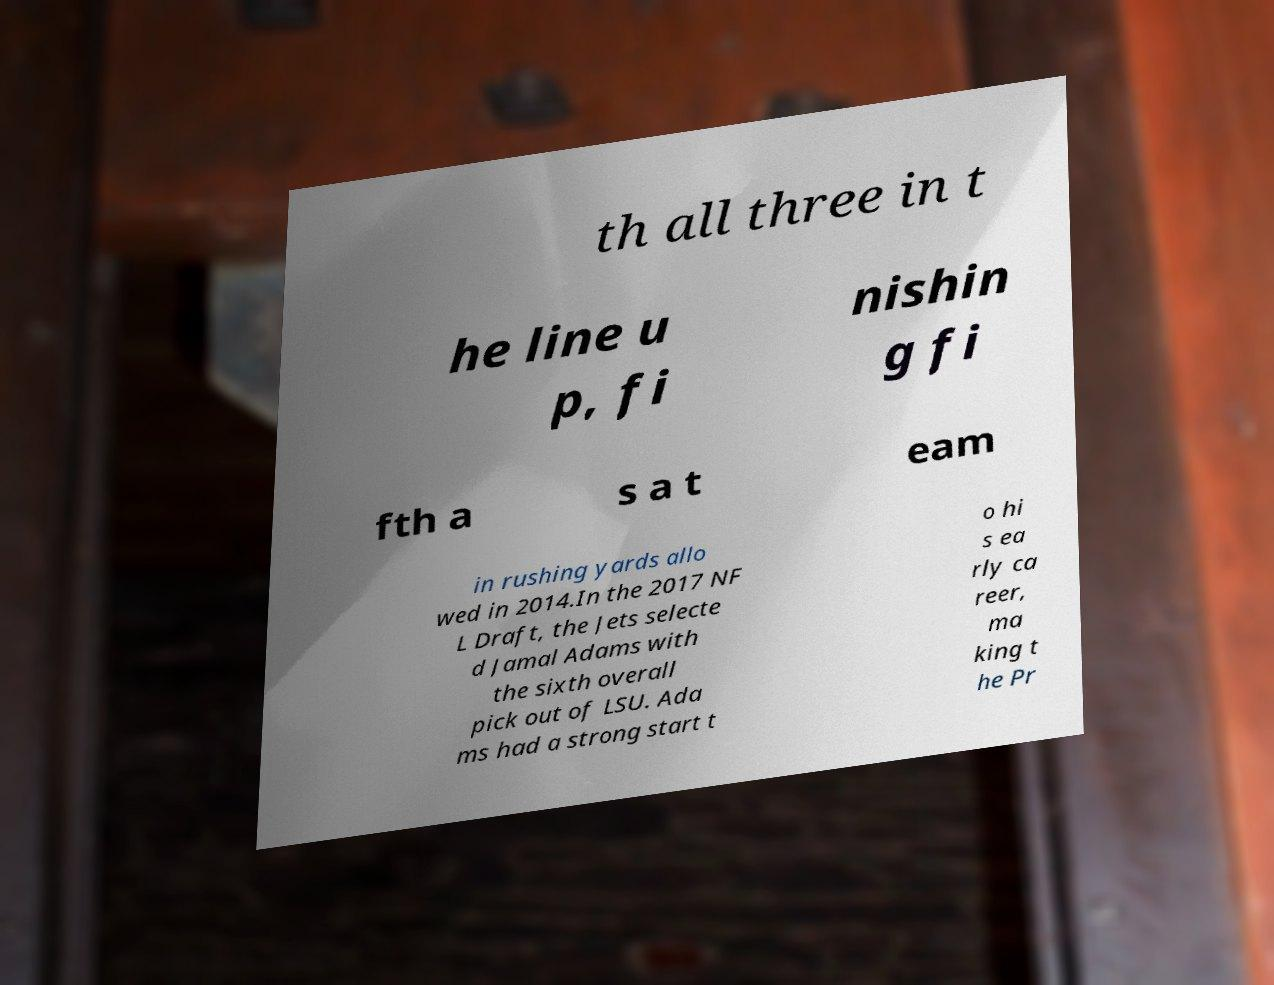I need the written content from this picture converted into text. Can you do that? th all three in t he line u p, fi nishin g fi fth a s a t eam in rushing yards allo wed in 2014.In the 2017 NF L Draft, the Jets selecte d Jamal Adams with the sixth overall pick out of LSU. Ada ms had a strong start t o hi s ea rly ca reer, ma king t he Pr 